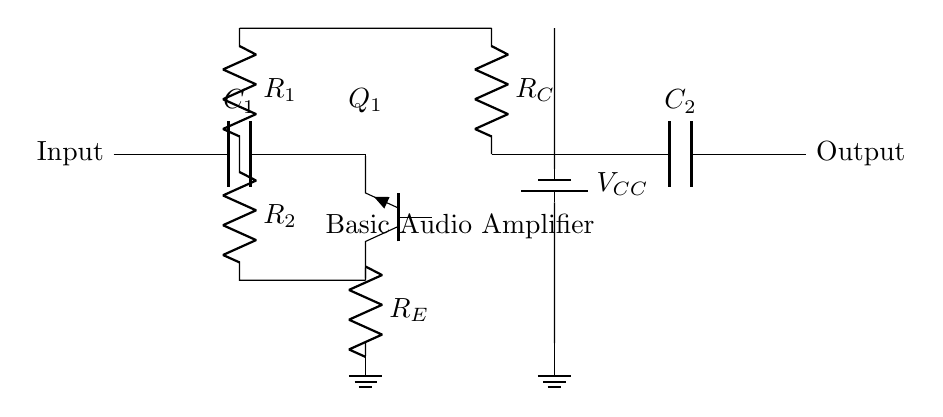what is the type of transistor used in the circuit? The circuit diagram shows a symbol labeled as "Tnpn," which indicates that an NPN transistor is used. NPN transistors are common in amplifier circuits.
Answer: NPN what is the function of capacitor C1? Capacitor C1 is connected at the input of the amplifier, and its primary function is to block any DC voltage while allowing AC signals (like audio signals) to pass through, effectively coupling the audio source to the transistor input.
Answer: Coupling what is the value of the supply voltage labeled in the circuit? The power supply in the circuit is labeled "V_CC," which does not provide a specific numerical value, but typically represents a positive voltage supply necessary for the operation of the circuit.
Answer: Not specified what is the role of resistor R_E in the circuit? Resistor R_E, labeled in the diagram, serves as the emitter resistor in the amplifier circuit. It helps stabilize the transistor's operating point and sets the gain of the amplifier.
Answer: Stabilization how does the output signal compare to the input signal? The output signal from the circuit is an amplified version of the input signal due to the amplification properties of the transistor, influenced by the values of resistors and capacitors in the circuit.
Answer: Amplified what happens if capacitor C2 is removed from the circuit? If capacitor C2 is removed, the output will likely be unable to block DC components, potentially leading to distortion in audio signals and poor performance since it might affect the coupling to subsequent stages.
Answer: Distortion what is the purpose of resistor R_C in the circuit? Resistor R_C, located between the transistor collector and the power supply, allows for the load to be connected and essentially sets the output level of the amplifier by determining the collector current and thereby influencing the gain of the amplifier.
Answer: Output level 